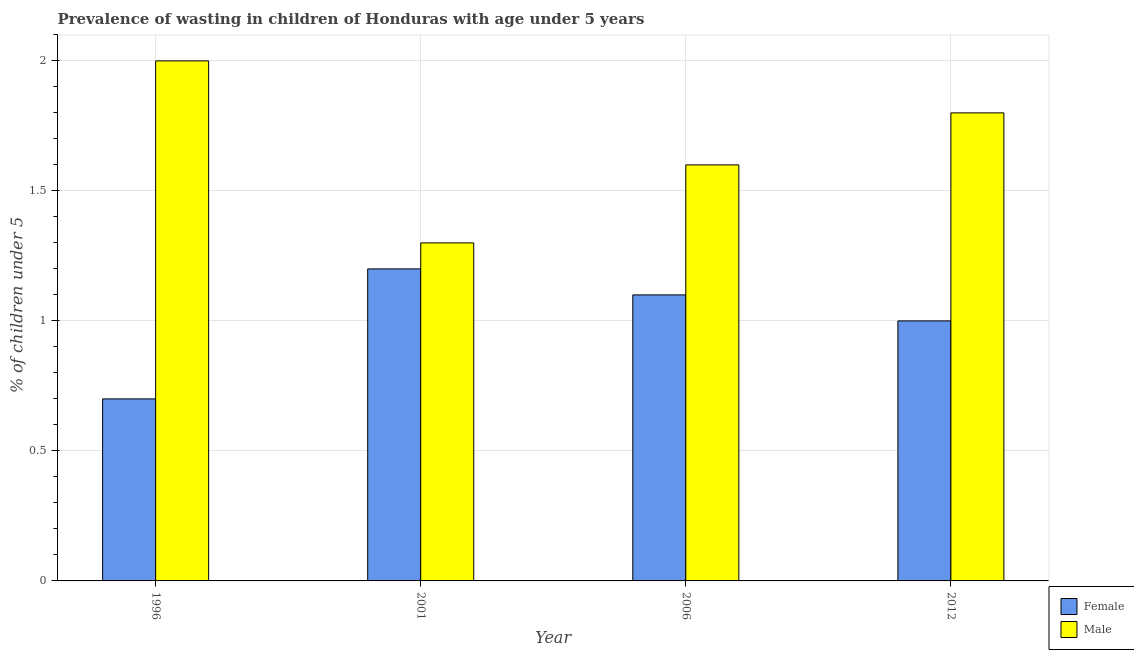How many different coloured bars are there?
Give a very brief answer. 2. How many groups of bars are there?
Your response must be concise. 4. How many bars are there on the 3rd tick from the left?
Keep it short and to the point. 2. How many bars are there on the 3rd tick from the right?
Offer a terse response. 2. What is the label of the 3rd group of bars from the left?
Offer a terse response. 2006. In how many cases, is the number of bars for a given year not equal to the number of legend labels?
Make the answer very short. 0. What is the percentage of undernourished male children in 1996?
Your answer should be very brief. 2. Across all years, what is the maximum percentage of undernourished female children?
Offer a very short reply. 1.2. Across all years, what is the minimum percentage of undernourished female children?
Your response must be concise. 0.7. In which year was the percentage of undernourished female children maximum?
Give a very brief answer. 2001. In which year was the percentage of undernourished female children minimum?
Provide a short and direct response. 1996. What is the total percentage of undernourished male children in the graph?
Ensure brevity in your answer.  6.7. What is the difference between the percentage of undernourished male children in 2001 and that in 2006?
Ensure brevity in your answer.  -0.3. What is the difference between the percentage of undernourished female children in 1996 and the percentage of undernourished male children in 2006?
Your response must be concise. -0.4. What is the average percentage of undernourished female children per year?
Give a very brief answer. 1. What is the ratio of the percentage of undernourished male children in 1996 to that in 2001?
Provide a succinct answer. 1.54. Is the difference between the percentage of undernourished male children in 1996 and 2001 greater than the difference between the percentage of undernourished female children in 1996 and 2001?
Keep it short and to the point. No. What is the difference between the highest and the second highest percentage of undernourished female children?
Your response must be concise. 0.1. What is the difference between the highest and the lowest percentage of undernourished male children?
Your answer should be very brief. 0.7. In how many years, is the percentage of undernourished male children greater than the average percentage of undernourished male children taken over all years?
Provide a short and direct response. 2. What does the 2nd bar from the right in 2012 represents?
Make the answer very short. Female. How many bars are there?
Ensure brevity in your answer.  8. How many years are there in the graph?
Offer a very short reply. 4. Does the graph contain grids?
Keep it short and to the point. Yes. How many legend labels are there?
Your answer should be compact. 2. What is the title of the graph?
Ensure brevity in your answer.  Prevalence of wasting in children of Honduras with age under 5 years. Does "Working only" appear as one of the legend labels in the graph?
Give a very brief answer. No. What is the label or title of the X-axis?
Keep it short and to the point. Year. What is the label or title of the Y-axis?
Provide a succinct answer.  % of children under 5. What is the  % of children under 5 of Female in 1996?
Keep it short and to the point. 0.7. What is the  % of children under 5 of Male in 1996?
Keep it short and to the point. 2. What is the  % of children under 5 in Female in 2001?
Provide a succinct answer. 1.2. What is the  % of children under 5 of Male in 2001?
Ensure brevity in your answer.  1.3. What is the  % of children under 5 in Female in 2006?
Your answer should be very brief. 1.1. What is the  % of children under 5 in Male in 2006?
Offer a very short reply. 1.6. What is the  % of children under 5 in Female in 2012?
Offer a very short reply. 1. What is the  % of children under 5 of Male in 2012?
Ensure brevity in your answer.  1.8. Across all years, what is the maximum  % of children under 5 in Female?
Ensure brevity in your answer.  1.2. Across all years, what is the minimum  % of children under 5 in Female?
Your answer should be compact. 0.7. Across all years, what is the minimum  % of children under 5 of Male?
Provide a succinct answer. 1.3. What is the total  % of children under 5 of Female in the graph?
Offer a very short reply. 4. What is the total  % of children under 5 of Male in the graph?
Give a very brief answer. 6.7. What is the difference between the  % of children under 5 of Male in 1996 and that in 2001?
Give a very brief answer. 0.7. What is the difference between the  % of children under 5 in Male in 1996 and that in 2006?
Offer a very short reply. 0.4. What is the difference between the  % of children under 5 in Male in 1996 and that in 2012?
Make the answer very short. 0.2. What is the difference between the  % of children under 5 of Female in 2001 and that in 2006?
Offer a terse response. 0.1. What is the difference between the  % of children under 5 of Male in 2001 and that in 2006?
Provide a succinct answer. -0.3. What is the difference between the  % of children under 5 in Male in 2001 and that in 2012?
Provide a succinct answer. -0.5. What is the difference between the  % of children under 5 of Male in 2006 and that in 2012?
Provide a succinct answer. -0.2. What is the difference between the  % of children under 5 of Female in 1996 and the  % of children under 5 of Male in 2012?
Keep it short and to the point. -1.1. What is the difference between the  % of children under 5 of Female in 2001 and the  % of children under 5 of Male in 2006?
Provide a succinct answer. -0.4. What is the difference between the  % of children under 5 of Female in 2001 and the  % of children under 5 of Male in 2012?
Provide a succinct answer. -0.6. What is the difference between the  % of children under 5 of Female in 2006 and the  % of children under 5 of Male in 2012?
Your answer should be compact. -0.7. What is the average  % of children under 5 of Male per year?
Provide a succinct answer. 1.68. In the year 1996, what is the difference between the  % of children under 5 of Female and  % of children under 5 of Male?
Your response must be concise. -1.3. In the year 2006, what is the difference between the  % of children under 5 in Female and  % of children under 5 in Male?
Provide a succinct answer. -0.5. In the year 2012, what is the difference between the  % of children under 5 in Female and  % of children under 5 in Male?
Provide a succinct answer. -0.8. What is the ratio of the  % of children under 5 of Female in 1996 to that in 2001?
Offer a very short reply. 0.58. What is the ratio of the  % of children under 5 in Male in 1996 to that in 2001?
Provide a succinct answer. 1.54. What is the ratio of the  % of children under 5 of Female in 1996 to that in 2006?
Offer a terse response. 0.64. What is the ratio of the  % of children under 5 in Male in 1996 to that in 2006?
Ensure brevity in your answer.  1.25. What is the ratio of the  % of children under 5 in Female in 2001 to that in 2006?
Provide a succinct answer. 1.09. What is the ratio of the  % of children under 5 in Male in 2001 to that in 2006?
Provide a succinct answer. 0.81. What is the ratio of the  % of children under 5 of Female in 2001 to that in 2012?
Ensure brevity in your answer.  1.2. What is the ratio of the  % of children under 5 of Male in 2001 to that in 2012?
Provide a short and direct response. 0.72. What is the difference between the highest and the lowest  % of children under 5 in Female?
Provide a succinct answer. 0.5. 